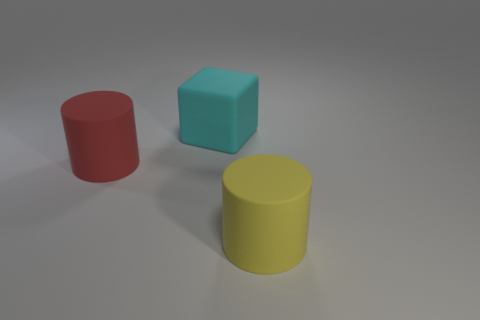Do the big yellow matte thing in front of the red rubber cylinder and the large thing that is on the left side of the large cyan rubber cube have the same shape?
Ensure brevity in your answer.  Yes. Is the number of matte blocks greater than the number of large objects?
Make the answer very short. No. Do the cylinder in front of the red object and the red object have the same material?
Offer a very short reply. Yes. Is the number of cubes in front of the big yellow thing less than the number of big objects right of the big red rubber cylinder?
Provide a short and direct response. Yes. What number of other objects are the same material as the red object?
Your answer should be compact. 2. Is the number of large cyan cubes behind the cyan cube less than the number of red rubber spheres?
Give a very brief answer. No. The matte thing that is in front of the cylinder that is behind the rubber cylinder on the right side of the big cyan cube is what shape?
Give a very brief answer. Cylinder. There is a thing to the left of the matte cube; what is its size?
Give a very brief answer. Large. What is the shape of the cyan matte object that is the same size as the yellow matte cylinder?
Ensure brevity in your answer.  Cube. What number of objects are big spheres or rubber things on the right side of the large red matte object?
Make the answer very short. 2. 